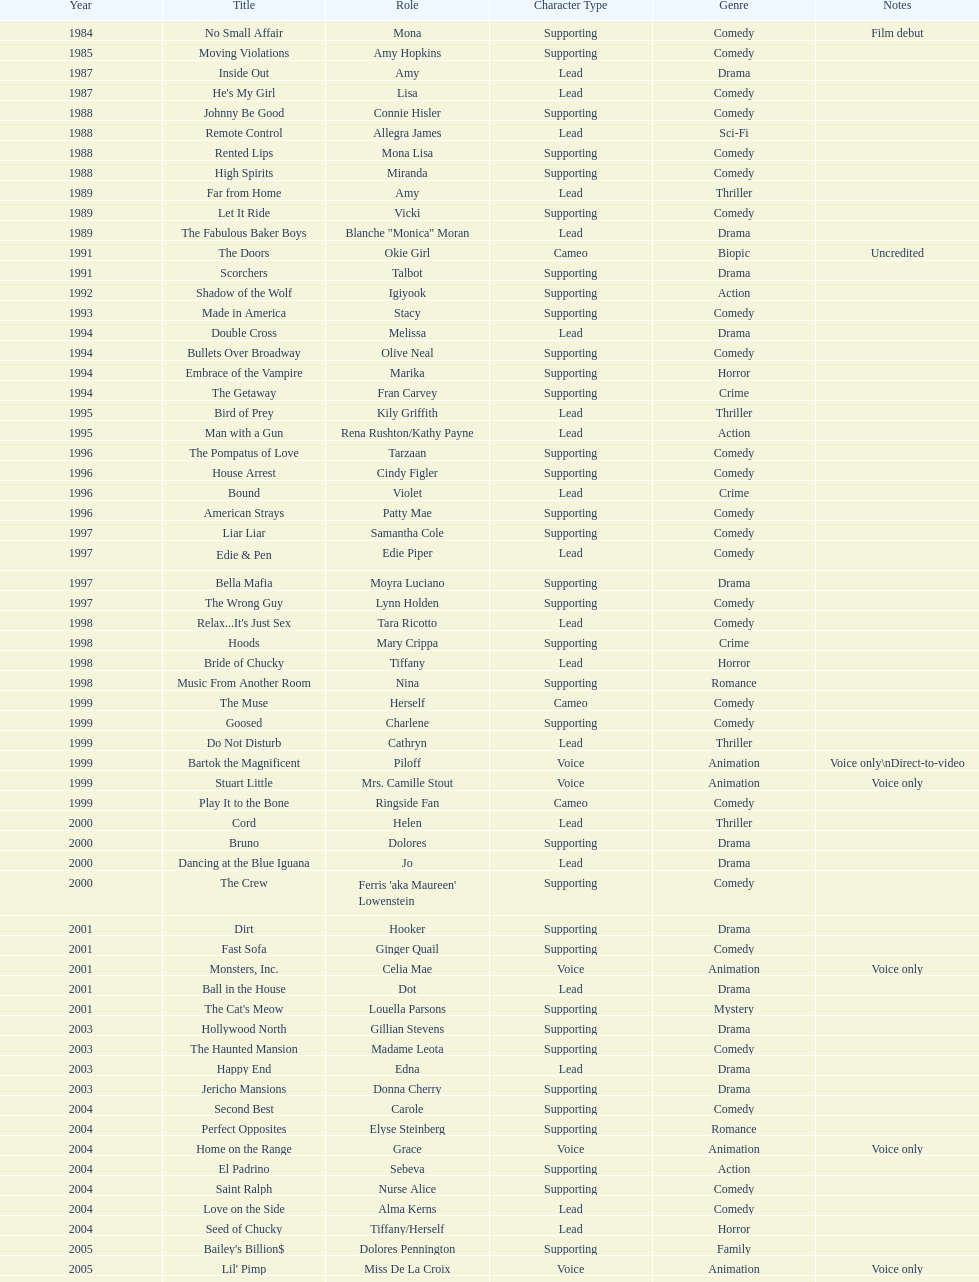Which film aired in 1994 and has marika as the role? Embrace of the Vampire. 